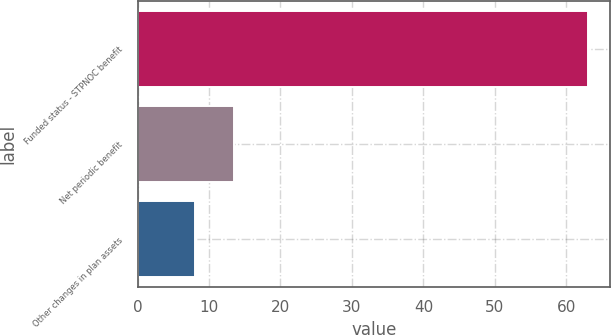<chart> <loc_0><loc_0><loc_500><loc_500><bar_chart><fcel>Funded status - STPNOC benefit<fcel>Net periodic benefit<fcel>Other changes in plan assets<nl><fcel>63<fcel>13.5<fcel>8<nl></chart> 